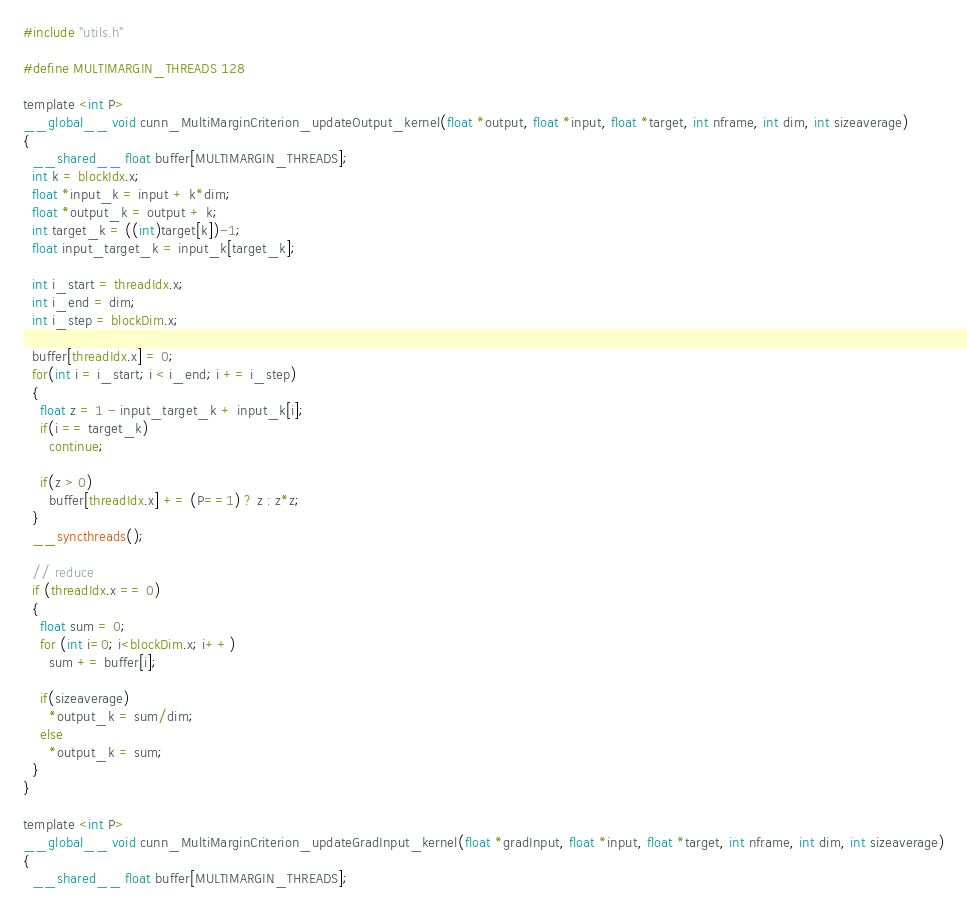Convert code to text. <code><loc_0><loc_0><loc_500><loc_500><_Cuda_>#include "utils.h"

#define MULTIMARGIN_THREADS 128

template <int P>
__global__ void cunn_MultiMarginCriterion_updateOutput_kernel(float *output, float *input, float *target, int nframe, int dim, int sizeaverage)
{
  __shared__ float buffer[MULTIMARGIN_THREADS];
  int k = blockIdx.x;
  float *input_k = input + k*dim;
  float *output_k = output + k;
  int target_k = ((int)target[k])-1;
  float input_target_k = input_k[target_k];

  int i_start = threadIdx.x;
  int i_end = dim;
  int i_step = blockDim.x;

  buffer[threadIdx.x] = 0;
  for(int i = i_start; i < i_end; i += i_step)
  {
    float z = 1 - input_target_k + input_k[i];
    if(i == target_k)
      continue;

    if(z > 0)
      buffer[threadIdx.x] += (P==1) ? z : z*z;
  }
  __syncthreads();

  // reduce
  if (threadIdx.x == 0)
  {
    float sum = 0;
    for (int i=0; i<blockDim.x; i++)
      sum += buffer[i];

    if(sizeaverage)
      *output_k = sum/dim;
    else
      *output_k = sum;
  }
}

template <int P>
__global__ void cunn_MultiMarginCriterion_updateGradInput_kernel(float *gradInput, float *input, float *target, int nframe, int dim, int sizeaverage)
{
  __shared__ float buffer[MULTIMARGIN_THREADS];</code> 